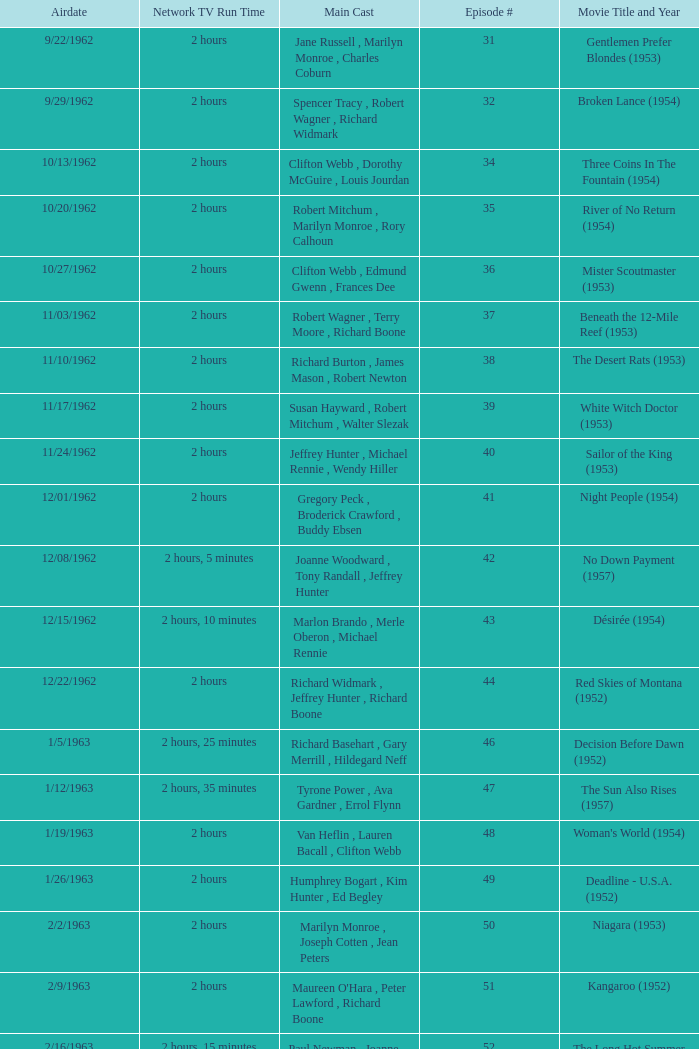What movie did dana wynter , mel ferrer , theodore bikel star in? Fraulein (1958). 